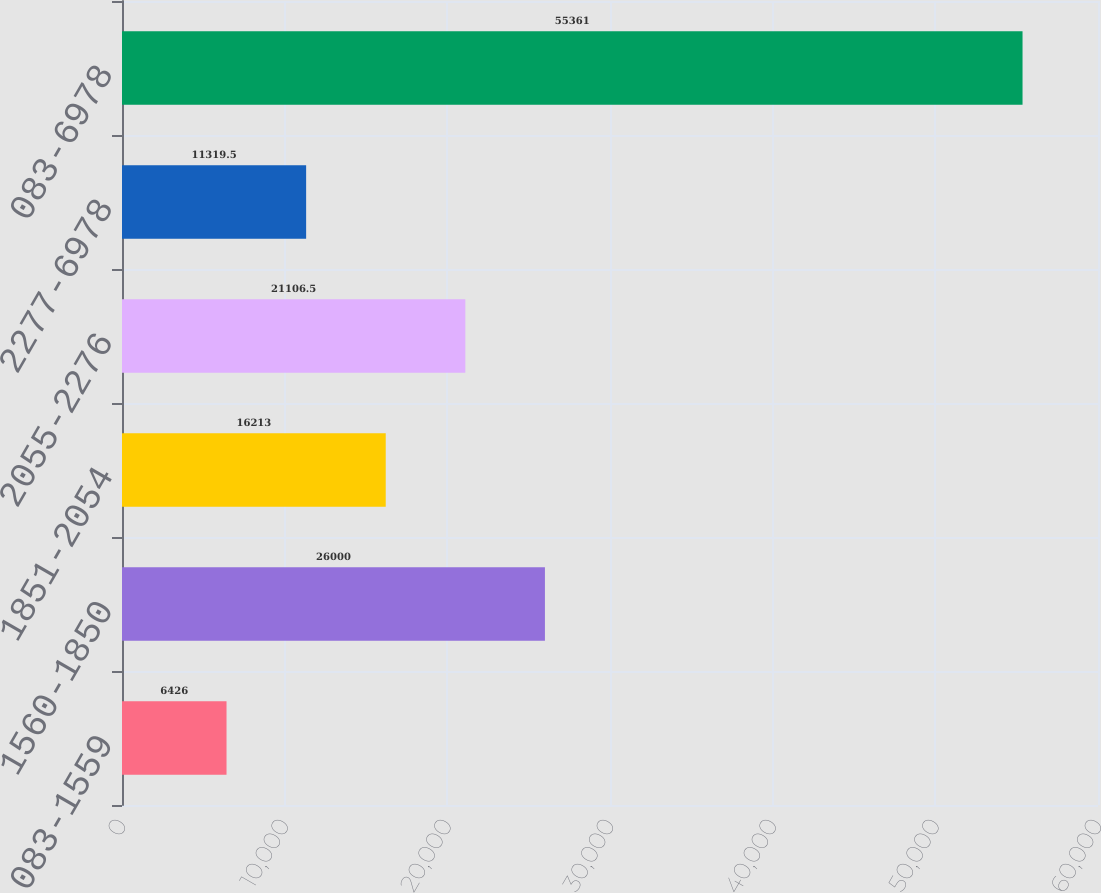Convert chart to OTSL. <chart><loc_0><loc_0><loc_500><loc_500><bar_chart><fcel>083-1559<fcel>1560-1850<fcel>1851-2054<fcel>2055-2276<fcel>2277-6978<fcel>083-6978<nl><fcel>6426<fcel>26000<fcel>16213<fcel>21106.5<fcel>11319.5<fcel>55361<nl></chart> 